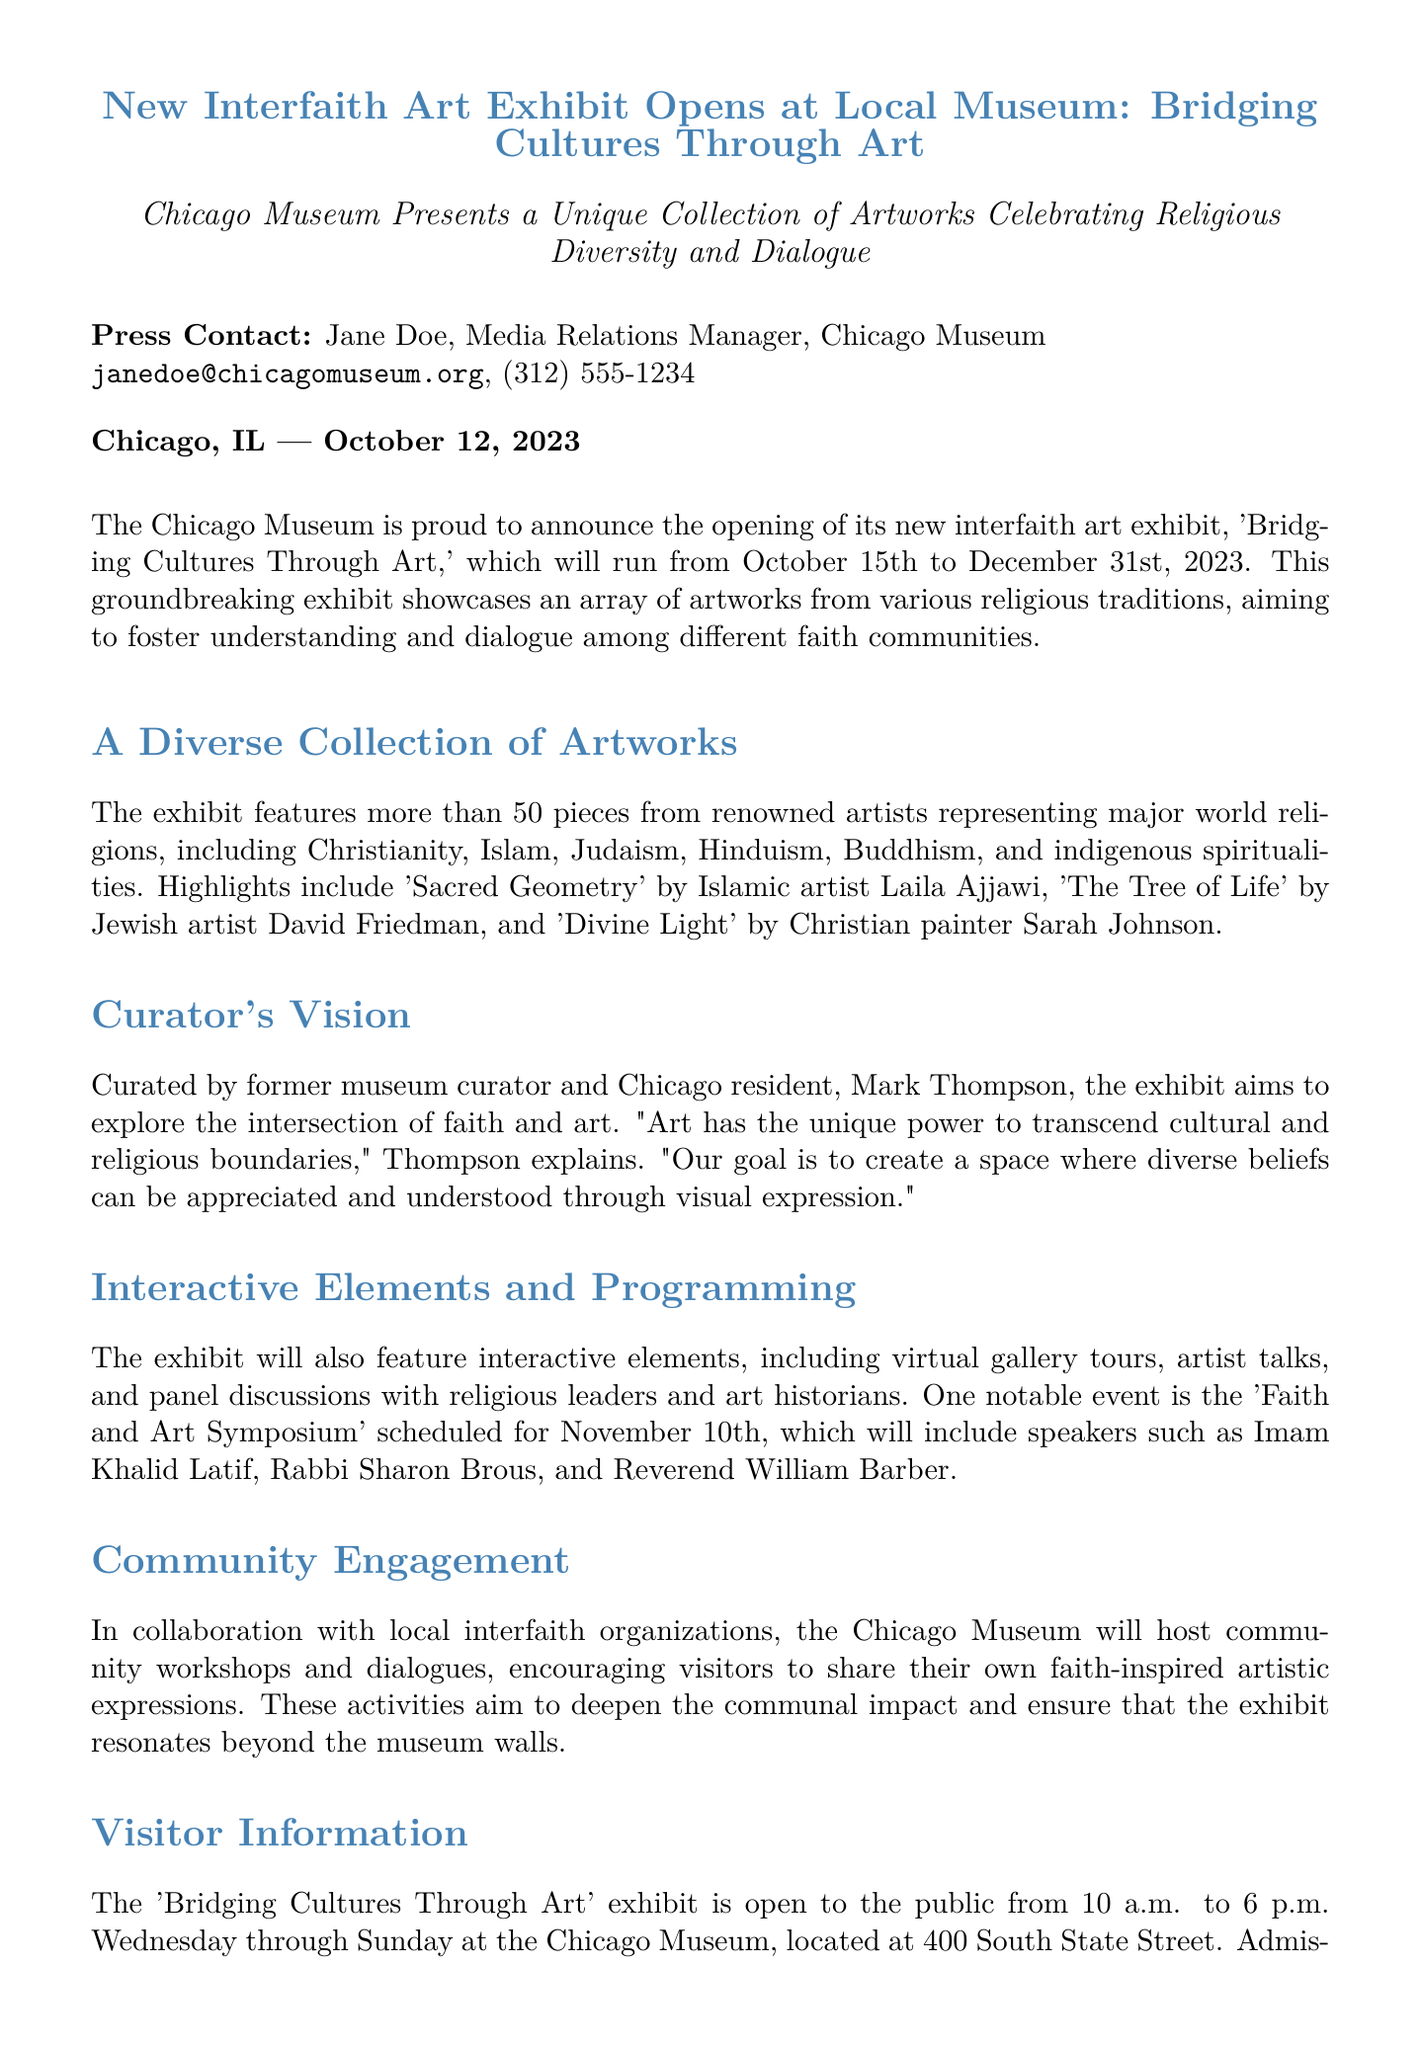What is the title of the exhibit? The title of the exhibit is the main subject mentioned in the document, which is 'Bridging Cultures Through Art.'
Answer: Bridging Cultures Through Art When does the exhibit open? The opening date is specifically stated in the press release as October 15th, 2023.
Answer: October 15th, 2023 How many pieces are featured in the exhibit? The number of pieces is explicitly mentioned as more than 50 artworks.
Answer: More than 50 Who is the curator of the exhibit? The curator's name is provided in the document as Mark Thompson.
Answer: Mark Thompson What is the main goal of the exhibit? The main goal is to foster understanding and dialogue among different faith communities, as stated in the press release.
Answer: Foster understanding and dialogue What significant event is scheduled for November 10th? The event mentioned is the 'Faith and Art Symposium,' which will take place on that date.
Answer: Faith and Art Symposium What is the admission fee for non-members? The admission fee is listed in the visitor information section as $15 for non-members.
Answer: $15 Which religions are represented in the exhibit? The religions mentioned in the document include Christianity, Islam, Judaism, Hinduism, Buddhism, and indigenous spiritualities.
Answer: Christianity, Islam, Judaism, Hinduism, Buddhism, indigenous spiritualities What type of community engagement activities are included? The community engagement activities involve workshops and dialogues to share faith-inspired artistic expressions.
Answer: Workshops and dialogues 